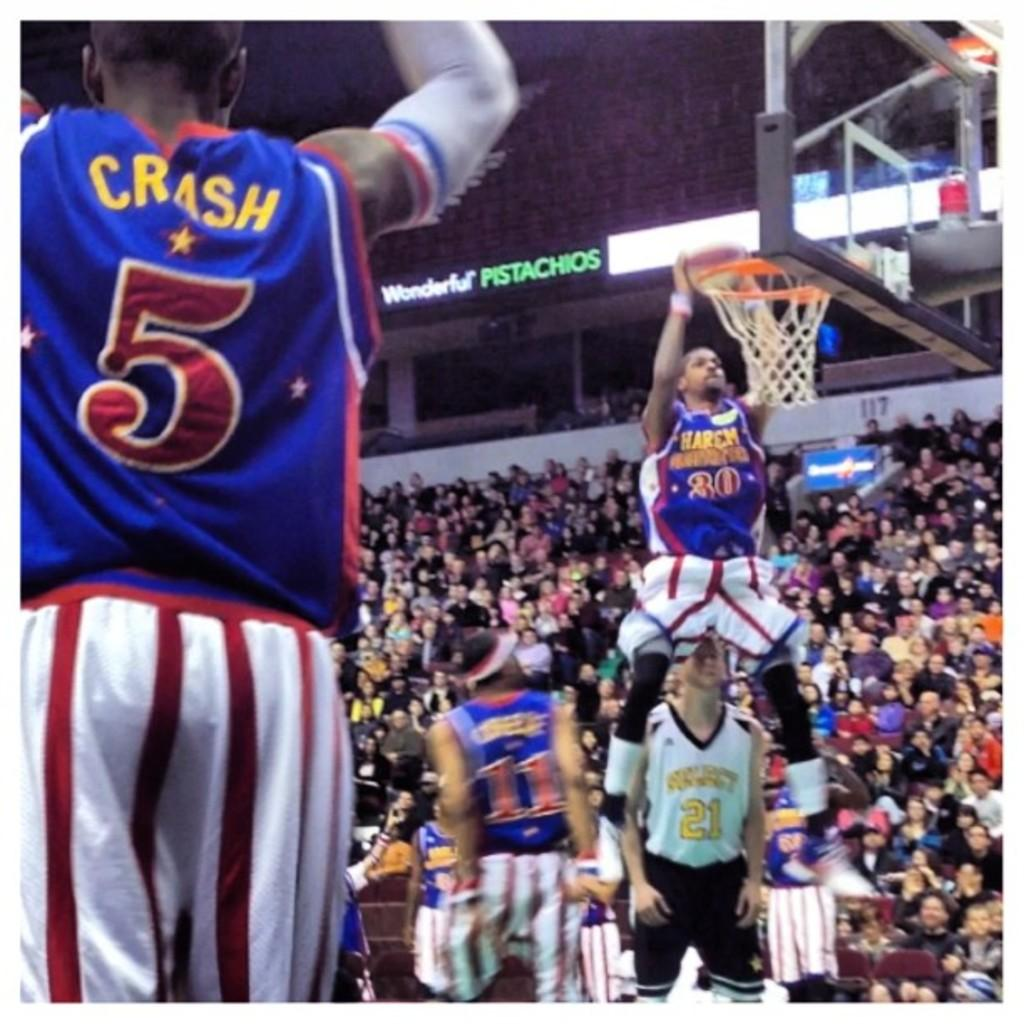<image>
Offer a succinct explanation of the picture presented. Number 20 for the Harlem Globetrotters gets ready to dunk while number 5 Crash stands by. 